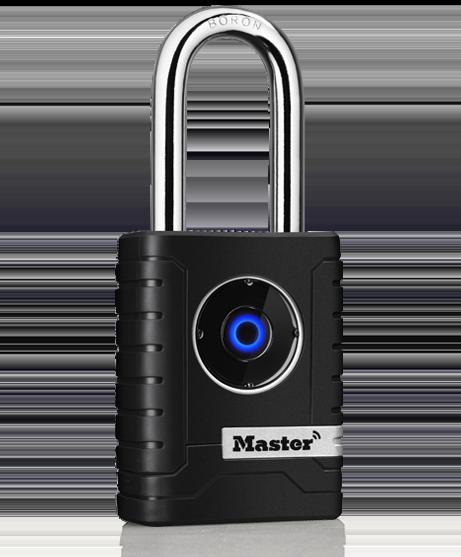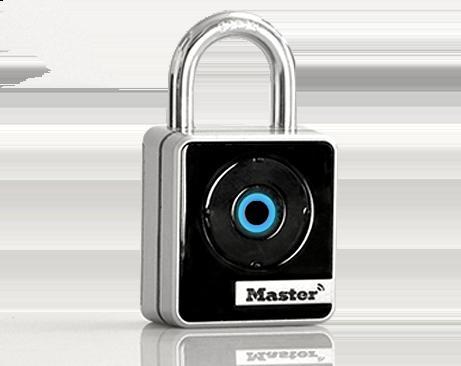The first image is the image on the left, the second image is the image on the right. For the images shown, is this caption "Exactly two locks are shown, both of them locked and with a circular design and logo on the front, one with ridges on each side." true? Answer yes or no. Yes. The first image is the image on the left, the second image is the image on the right. Evaluate the accuracy of this statement regarding the images: "Each image contains just one lock, which is upright and has a blue circle on the front.". Is it true? Answer yes or no. Yes. 